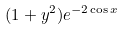<formula> <loc_0><loc_0><loc_500><loc_500>( 1 + y ^ { 2 } ) e ^ { - 2 \cos x }</formula> 